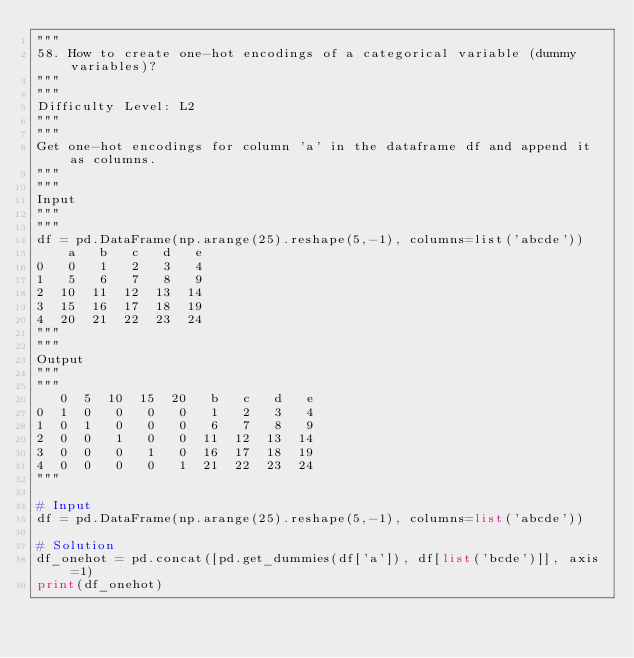Convert code to text. <code><loc_0><loc_0><loc_500><loc_500><_Python_>"""
58. How to create one-hot encodings of a categorical variable (dummy variables)?
"""
"""
Difficulty Level: L2
"""
"""
Get one-hot encodings for column 'a' in the dataframe df and append it as columns.
"""
"""
Input
"""
"""
df = pd.DataFrame(np.arange(25).reshape(5,-1), columns=list('abcde'))
    a   b   c   d   e
0   0   1   2   3   4
1   5   6   7   8   9
2  10  11  12  13  14
3  15  16  17  18  19
4  20  21  22  23  24
"""
"""
Output
"""
"""
   0  5  10  15  20   b   c   d   e
0  1  0   0   0   0   1   2   3   4
1  0  1   0   0   0   6   7   8   9
2  0  0   1   0   0  11  12  13  14
3  0  0   0   1   0  16  17  18  19
4  0  0   0   0   1  21  22  23  24
"""

# Input
df = pd.DataFrame(np.arange(25).reshape(5,-1), columns=list('abcde'))

# Solution
df_onehot = pd.concat([pd.get_dummies(df['a']), df[list('bcde')]], axis=1)
print(df_onehot)</code> 